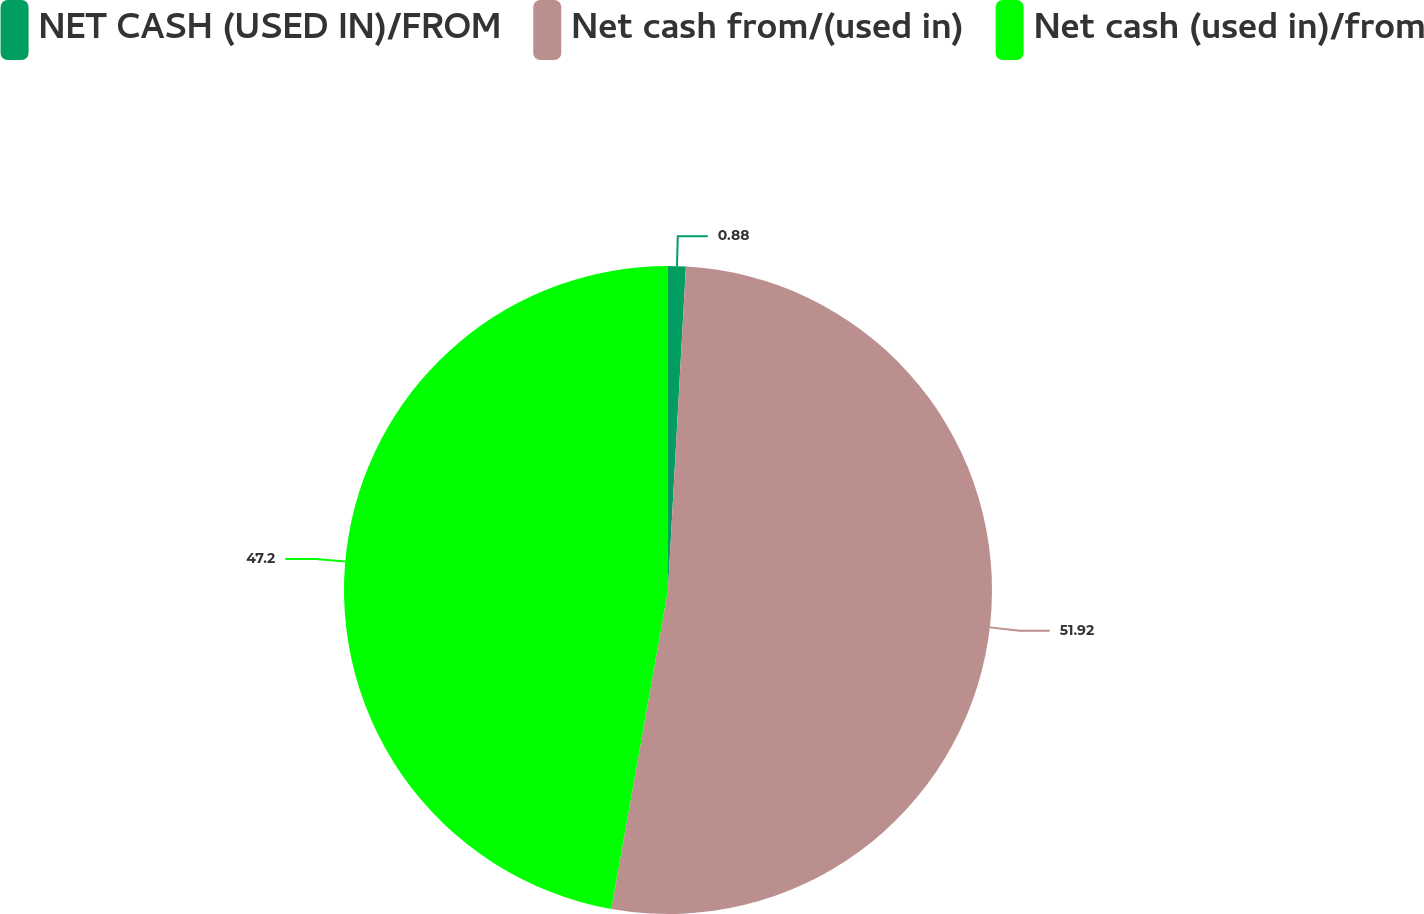Convert chart to OTSL. <chart><loc_0><loc_0><loc_500><loc_500><pie_chart><fcel>NET CASH (USED IN)/FROM<fcel>Net cash from/(used in)<fcel>Net cash (used in)/from<nl><fcel>0.88%<fcel>51.92%<fcel>47.2%<nl></chart> 